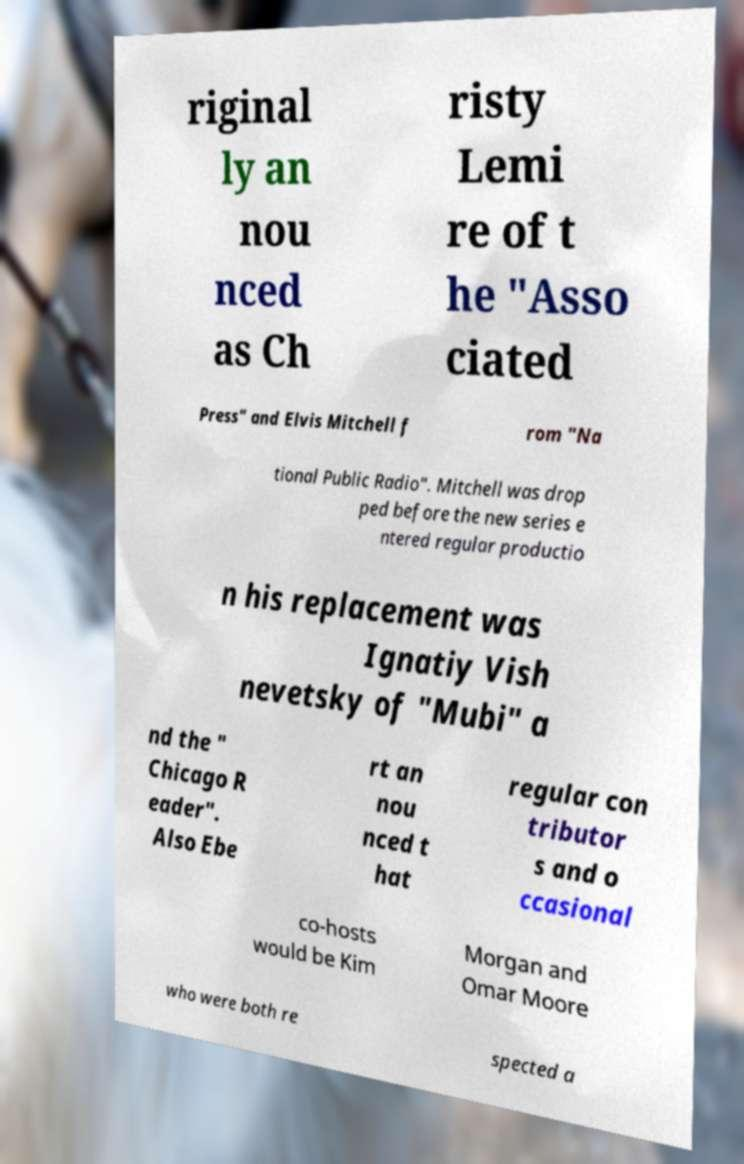I need the written content from this picture converted into text. Can you do that? riginal ly an nou nced as Ch risty Lemi re of t he "Asso ciated Press" and Elvis Mitchell f rom "Na tional Public Radio". Mitchell was drop ped before the new series e ntered regular productio n his replacement was Ignatiy Vish nevetsky of "Mubi" a nd the " Chicago R eader". Also Ebe rt an nou nced t hat regular con tributor s and o ccasional co-hosts would be Kim Morgan and Omar Moore who were both re spected a 